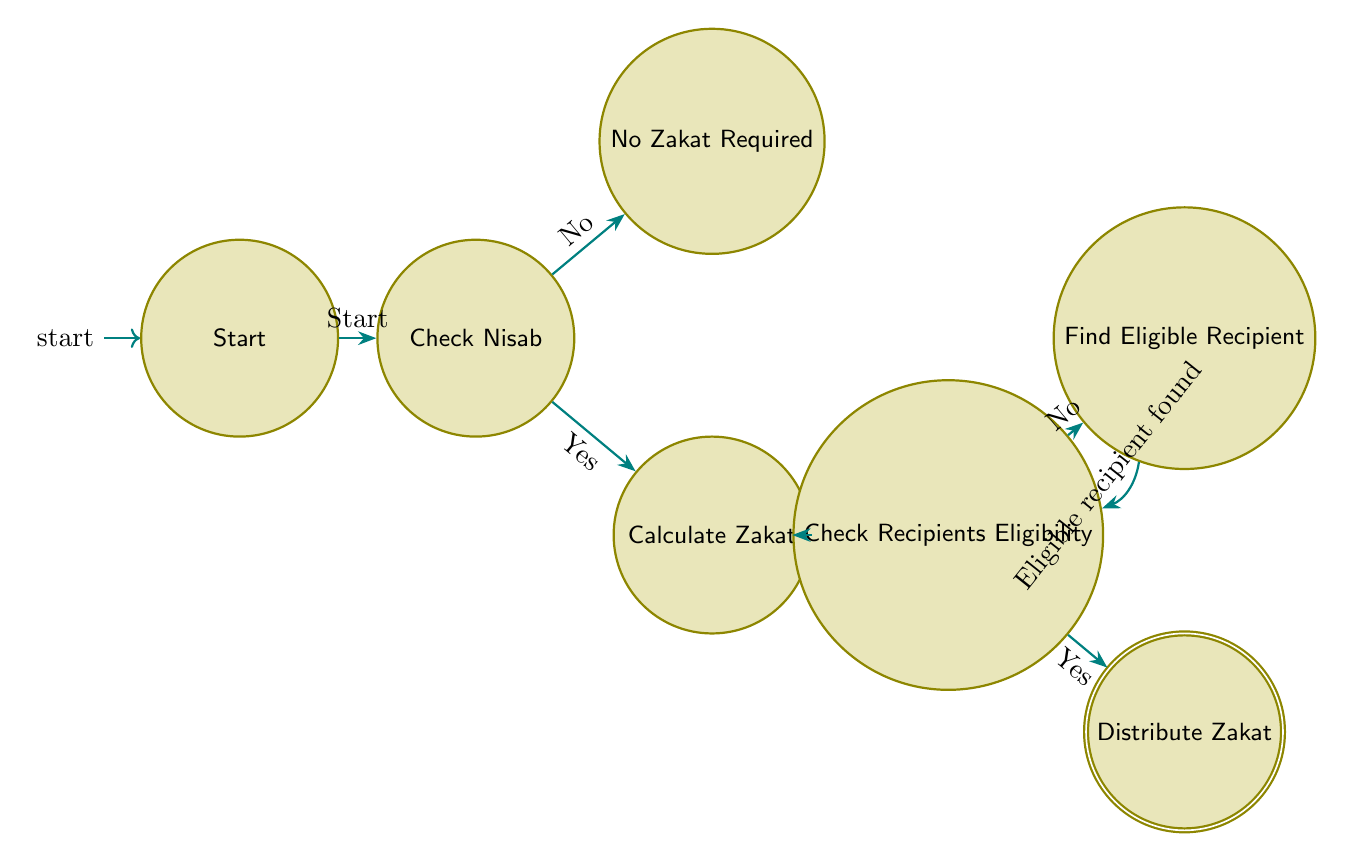What is the initial node in the diagram? The initial node is labeled "Start," which indicates where the decision flow begins.
Answer: Start How many decision nodes are present in the diagram? There are two decision nodes: "Check Nisab" and "Check Recipients Eligibility."
Answer: 2 What happens if you do not meet the Nisab threshold? If you do not meet the Nisab threshold, the flow leads to the "No Zakat Required" node, which indicates that you are not required to give Zakat.
Answer: No Zakat Required What is the process that follows after confirming the Nisab threshold? After confirming the Nisab threshold, the next process is to "Calculate Zakat," where you determine 2.5% of your savings and eligible assets.
Answer: Calculate Zakat What is the final output if the recipient is eligible for Zakat? If the recipient is eligible for Zakat, the final action is to "Distribute Zakat" to the eligible recipient.
Answer: Distribute Zakat Which node leads from "Check Recipients Eligibility" if the recipient is not eligible? If the recipient is not eligible, the flow leads to the "Find Eligible Recipient" node instead of directly distributing Zakat.
Answer: Find Eligible Recipient What condition allows the flow to return to the "Check Recipients Eligibility" node? The condition that allows the flow to return is when an "Eligible recipient found" is identified, indicating that you should re-evaluate recipients for Zakat distribution.
Answer: Eligible recipient found What is the percentage of savings calculated for Zakat? The percentage of savings calculated for Zakat is 2.5%.
Answer: 2.5% 